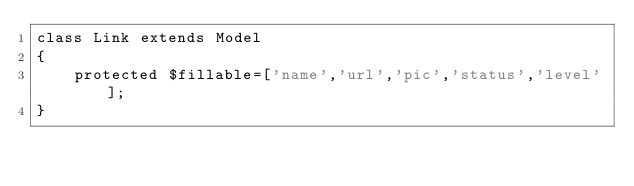Convert code to text. <code><loc_0><loc_0><loc_500><loc_500><_PHP_>class Link extends Model
{
    protected $fillable=['name','url','pic','status','level'];
}
</code> 